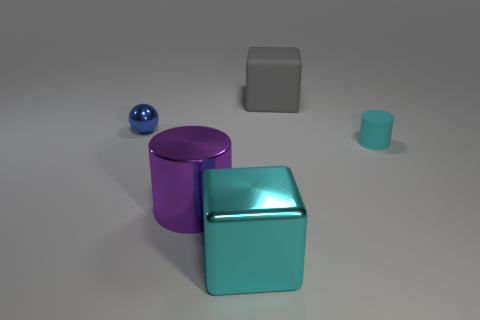Is the shiny sphere the same size as the cyan cube?
Your answer should be very brief. No. How many things are small objects to the left of the gray matte thing or tiny purple rubber cubes?
Ensure brevity in your answer.  1. What material is the large cube that is in front of the small blue metallic ball that is behind the tiny cyan matte object?
Your answer should be compact. Metal. Is there a matte thing of the same shape as the big cyan shiny thing?
Keep it short and to the point. Yes. Is the size of the metal ball the same as the metal object in front of the purple object?
Your response must be concise. No. How many things are objects that are to the left of the shiny cylinder or cylinders that are right of the cyan metal cube?
Give a very brief answer. 2. Are there more large gray objects behind the large purple shiny cylinder than cyan metallic balls?
Ensure brevity in your answer.  Yes. How many cyan cubes have the same size as the gray object?
Offer a very short reply. 1. Do the cylinder that is on the left side of the large gray thing and the gray matte object behind the blue shiny sphere have the same size?
Provide a short and direct response. Yes. What is the size of the cyan object that is to the left of the tiny cyan rubber thing?
Your answer should be compact. Large. 